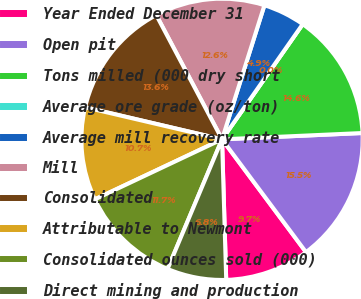Convert chart to OTSL. <chart><loc_0><loc_0><loc_500><loc_500><pie_chart><fcel>Year Ended December 31<fcel>Open pit<fcel>Tons milled (000 dry short<fcel>Average ore grade (oz/ton)<fcel>Average mill recovery rate<fcel>Mill<fcel>Consolidated<fcel>Attributable to Newmont<fcel>Consolidated ounces sold (000)<fcel>Direct mining and production<nl><fcel>9.71%<fcel>15.53%<fcel>14.56%<fcel>0.0%<fcel>4.85%<fcel>12.62%<fcel>13.59%<fcel>10.68%<fcel>11.65%<fcel>6.8%<nl></chart> 